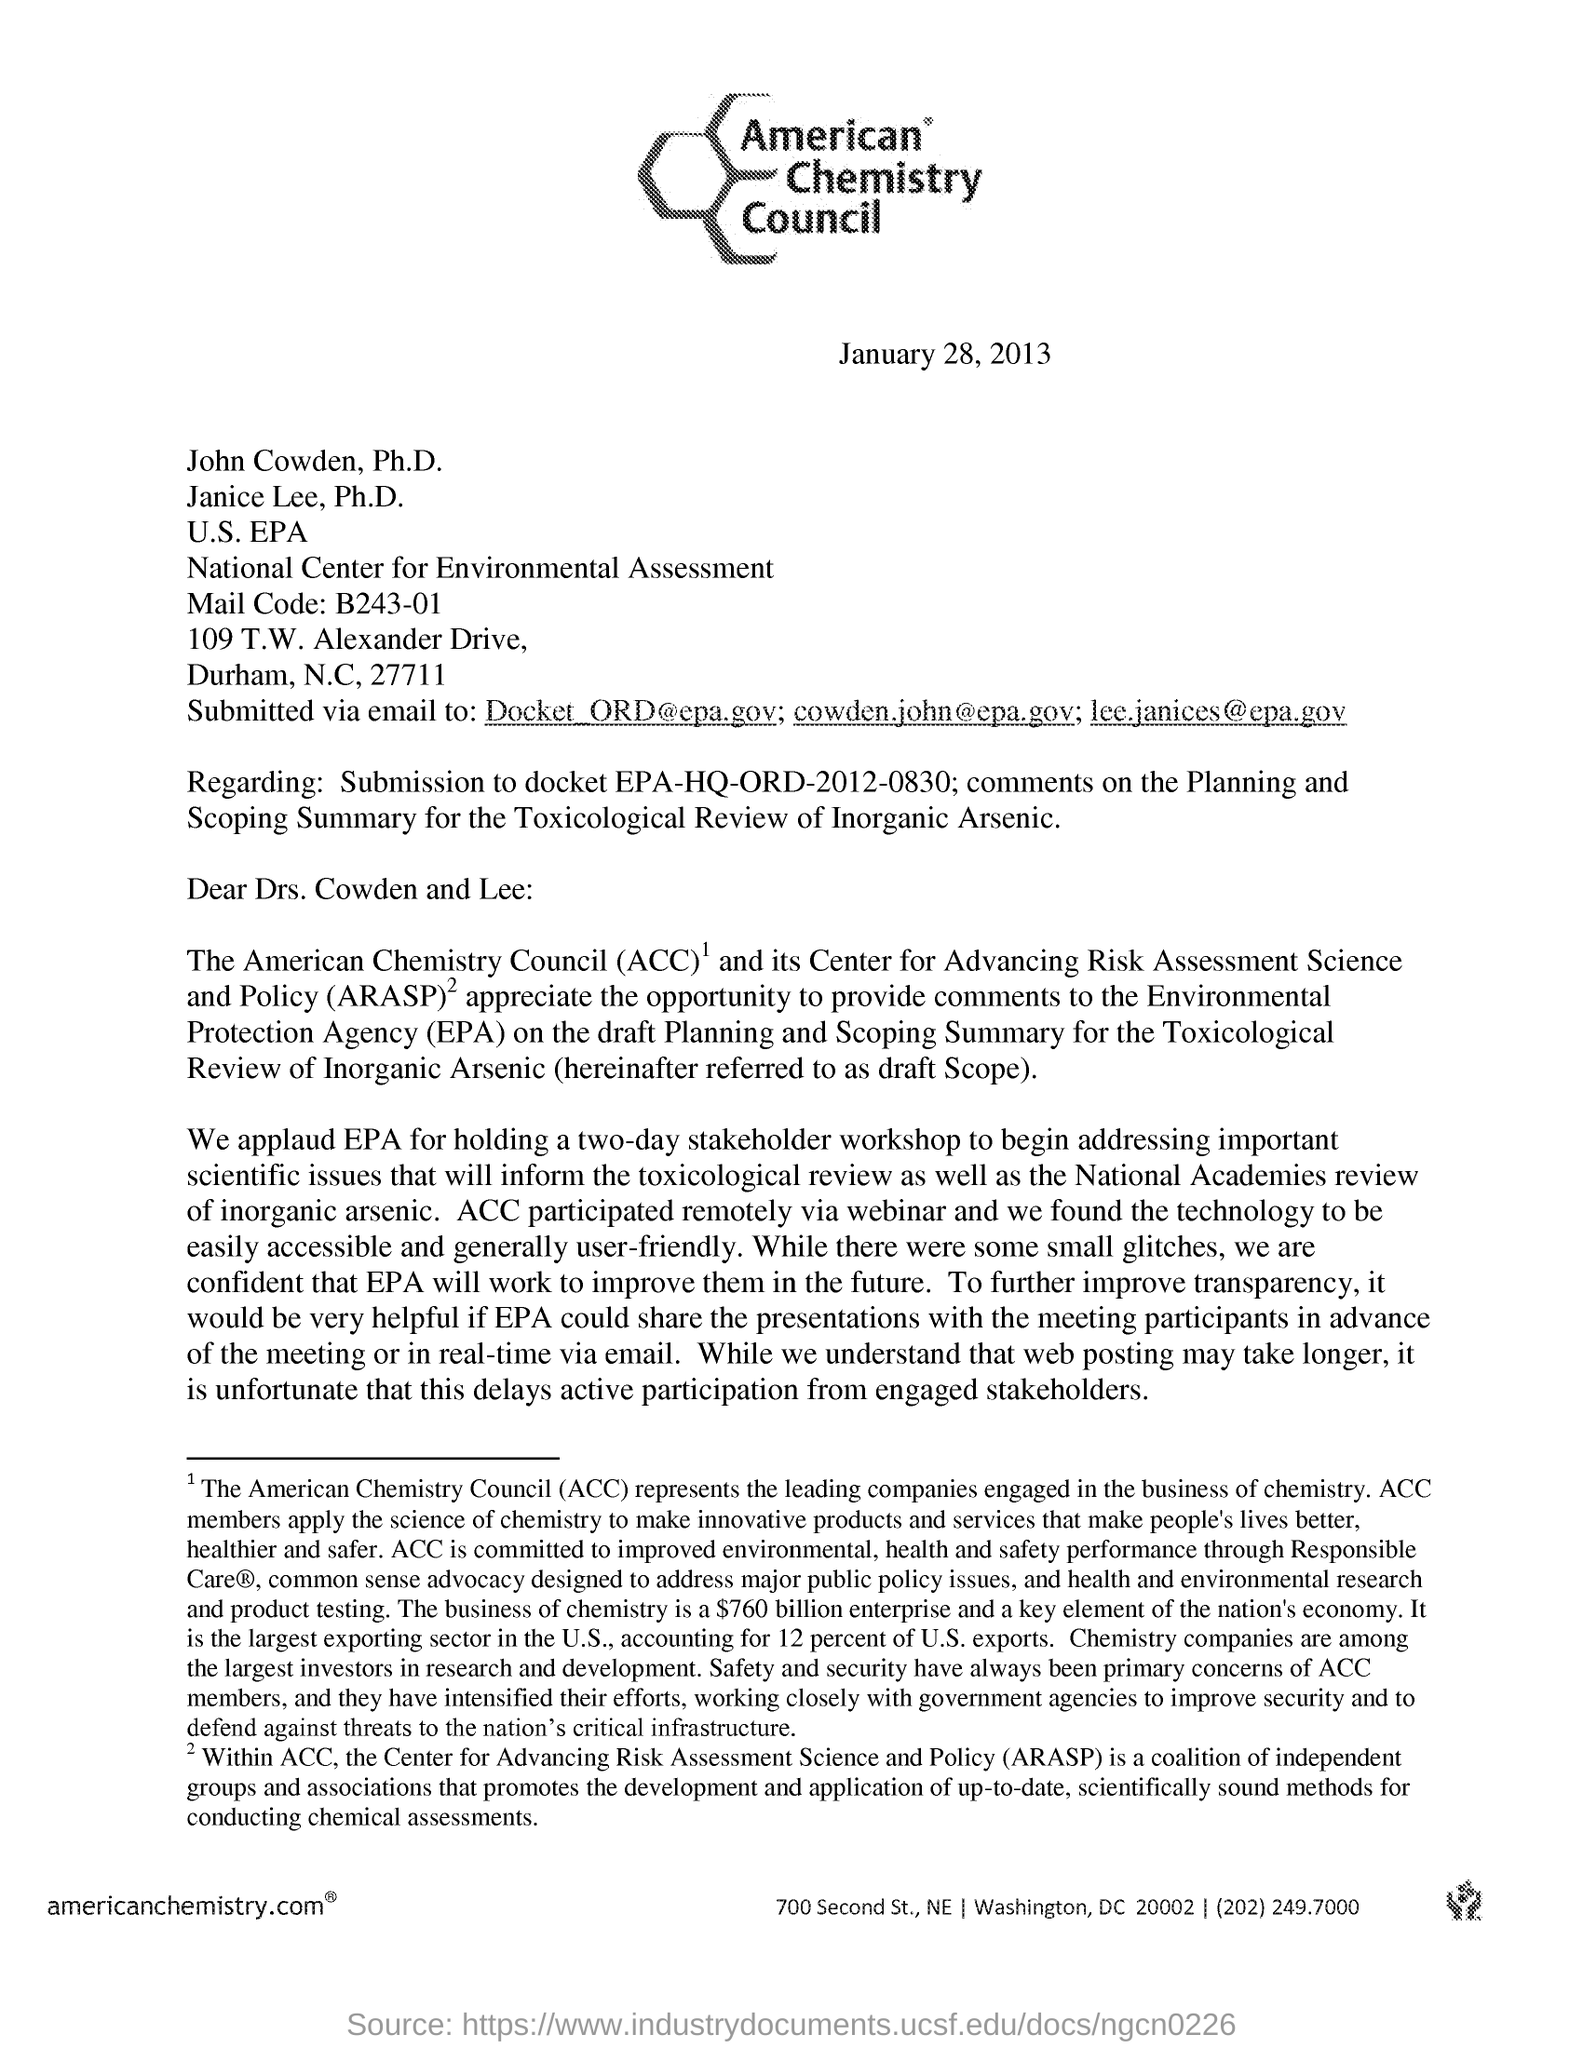Specify some key components in this picture. The recipients of this email are Dr. Cowden and Dr. Lee. The American Chemistry Council is an organization that represents the interests of the chemical industry in the United States. The date mentioned is January 28, 2013. The heading of the document is American Chemistry Council. 